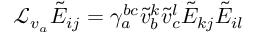Convert formula to latex. <formula><loc_0><loc_0><loc_500><loc_500>{ \mathcal { L } } _ { v _ { a } } \tilde { E } _ { i j } = \gamma _ { a } ^ { b c } \tilde { v } _ { b } ^ { k } \tilde { v } _ { c } ^ { l } \tilde { E } _ { k j } \tilde { E } _ { i l }</formula> 